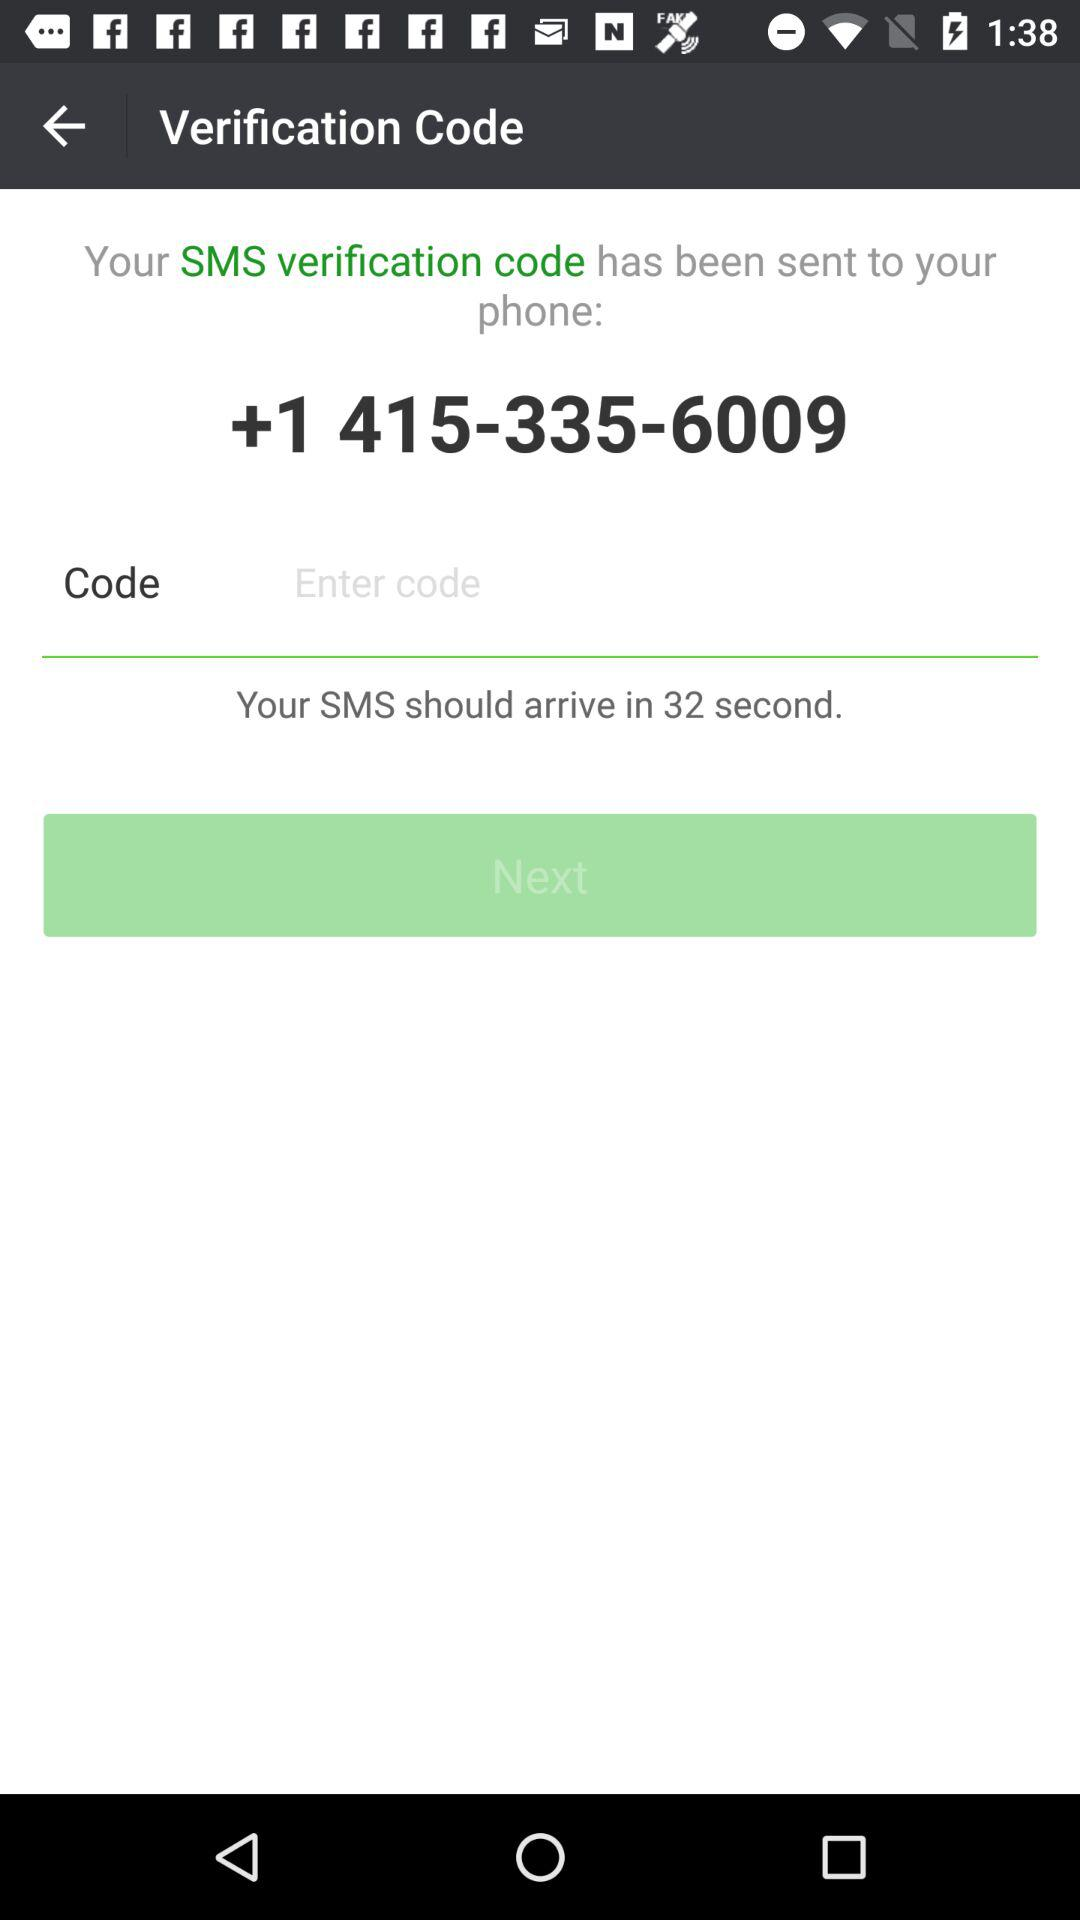How many seconds do I have to wait for my SMS verification code?
Answer the question using a single word or phrase. 32 